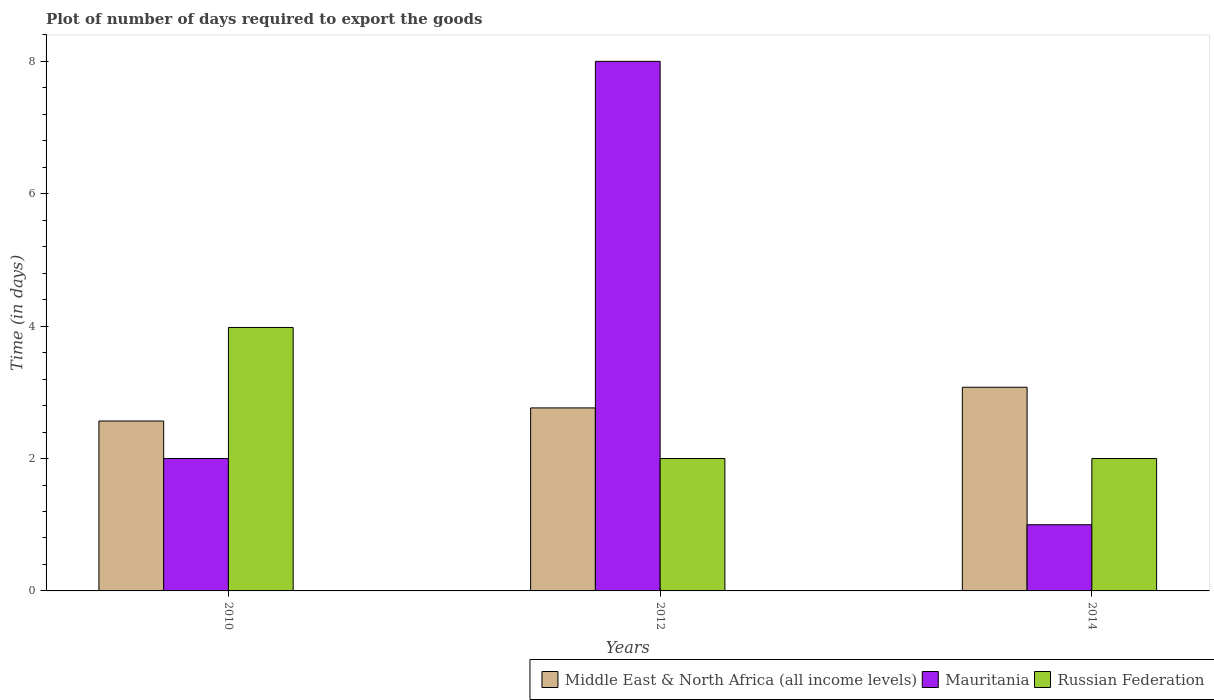How many bars are there on the 1st tick from the left?
Ensure brevity in your answer.  3. How many bars are there on the 2nd tick from the right?
Your response must be concise. 3. What is the label of the 3rd group of bars from the left?
Offer a very short reply. 2014. What is the time required to export goods in Mauritania in 2014?
Ensure brevity in your answer.  1. Across all years, what is the maximum time required to export goods in Russian Federation?
Provide a short and direct response. 3.98. Across all years, what is the minimum time required to export goods in Russian Federation?
Offer a very short reply. 2. In which year was the time required to export goods in Middle East & North Africa (all income levels) maximum?
Give a very brief answer. 2014. In which year was the time required to export goods in Russian Federation minimum?
Offer a very short reply. 2012. What is the difference between the time required to export goods in Mauritania in 2010 and that in 2012?
Offer a very short reply. -6. What is the difference between the time required to export goods in Russian Federation in 2010 and the time required to export goods in Mauritania in 2012?
Offer a terse response. -4.02. What is the average time required to export goods in Mauritania per year?
Your answer should be very brief. 3.67. In the year 2012, what is the difference between the time required to export goods in Russian Federation and time required to export goods in Middle East & North Africa (all income levels)?
Ensure brevity in your answer.  -0.76. What is the ratio of the time required to export goods in Middle East & North Africa (all income levels) in 2012 to that in 2014?
Your answer should be compact. 0.9. Is the time required to export goods in Mauritania in 2012 less than that in 2014?
Offer a terse response. No. What is the difference between the highest and the second highest time required to export goods in Middle East & North Africa (all income levels)?
Your answer should be very brief. 0.31. What is the difference between the highest and the lowest time required to export goods in Mauritania?
Offer a terse response. 7. In how many years, is the time required to export goods in Russian Federation greater than the average time required to export goods in Russian Federation taken over all years?
Offer a very short reply. 1. What does the 1st bar from the left in 2014 represents?
Your answer should be very brief. Middle East & North Africa (all income levels). What does the 2nd bar from the right in 2012 represents?
Provide a short and direct response. Mauritania. Are all the bars in the graph horizontal?
Your response must be concise. No. What is the difference between two consecutive major ticks on the Y-axis?
Offer a very short reply. 2. Are the values on the major ticks of Y-axis written in scientific E-notation?
Offer a very short reply. No. Does the graph contain any zero values?
Your response must be concise. No. Does the graph contain grids?
Give a very brief answer. No. How are the legend labels stacked?
Give a very brief answer. Horizontal. What is the title of the graph?
Your answer should be compact. Plot of number of days required to export the goods. Does "Comoros" appear as one of the legend labels in the graph?
Make the answer very short. No. What is the label or title of the X-axis?
Make the answer very short. Years. What is the label or title of the Y-axis?
Make the answer very short. Time (in days). What is the Time (in days) in Middle East & North Africa (all income levels) in 2010?
Offer a very short reply. 2.57. What is the Time (in days) of Mauritania in 2010?
Ensure brevity in your answer.  2. What is the Time (in days) in Russian Federation in 2010?
Ensure brevity in your answer.  3.98. What is the Time (in days) of Middle East & North Africa (all income levels) in 2012?
Offer a very short reply. 2.76. What is the Time (in days) of Mauritania in 2012?
Provide a succinct answer. 8. What is the Time (in days) of Russian Federation in 2012?
Your response must be concise. 2. What is the Time (in days) of Middle East & North Africa (all income levels) in 2014?
Your answer should be very brief. 3.08. What is the Time (in days) in Mauritania in 2014?
Give a very brief answer. 1. Across all years, what is the maximum Time (in days) in Middle East & North Africa (all income levels)?
Provide a succinct answer. 3.08. Across all years, what is the maximum Time (in days) in Russian Federation?
Your response must be concise. 3.98. Across all years, what is the minimum Time (in days) of Middle East & North Africa (all income levels)?
Provide a succinct answer. 2.57. Across all years, what is the minimum Time (in days) of Mauritania?
Your answer should be very brief. 1. Across all years, what is the minimum Time (in days) in Russian Federation?
Offer a terse response. 2. What is the total Time (in days) of Middle East & North Africa (all income levels) in the graph?
Offer a very short reply. 8.41. What is the total Time (in days) in Mauritania in the graph?
Ensure brevity in your answer.  11. What is the total Time (in days) in Russian Federation in the graph?
Your answer should be compact. 7.98. What is the difference between the Time (in days) of Middle East & North Africa (all income levels) in 2010 and that in 2012?
Your answer should be compact. -0.2. What is the difference between the Time (in days) in Russian Federation in 2010 and that in 2012?
Your answer should be compact. 1.98. What is the difference between the Time (in days) in Middle East & North Africa (all income levels) in 2010 and that in 2014?
Offer a very short reply. -0.51. What is the difference between the Time (in days) of Russian Federation in 2010 and that in 2014?
Provide a short and direct response. 1.98. What is the difference between the Time (in days) in Middle East & North Africa (all income levels) in 2012 and that in 2014?
Ensure brevity in your answer.  -0.31. What is the difference between the Time (in days) of Mauritania in 2012 and that in 2014?
Your response must be concise. 7. What is the difference between the Time (in days) of Russian Federation in 2012 and that in 2014?
Your answer should be very brief. 0. What is the difference between the Time (in days) of Middle East & North Africa (all income levels) in 2010 and the Time (in days) of Mauritania in 2012?
Offer a terse response. -5.43. What is the difference between the Time (in days) of Middle East & North Africa (all income levels) in 2010 and the Time (in days) of Russian Federation in 2012?
Ensure brevity in your answer.  0.57. What is the difference between the Time (in days) of Mauritania in 2010 and the Time (in days) of Russian Federation in 2012?
Provide a succinct answer. 0. What is the difference between the Time (in days) of Middle East & North Africa (all income levels) in 2010 and the Time (in days) of Mauritania in 2014?
Make the answer very short. 1.57. What is the difference between the Time (in days) in Middle East & North Africa (all income levels) in 2010 and the Time (in days) in Russian Federation in 2014?
Keep it short and to the point. 0.57. What is the difference between the Time (in days) of Mauritania in 2010 and the Time (in days) of Russian Federation in 2014?
Your response must be concise. 0. What is the difference between the Time (in days) of Middle East & North Africa (all income levels) in 2012 and the Time (in days) of Mauritania in 2014?
Provide a short and direct response. 1.76. What is the difference between the Time (in days) in Middle East & North Africa (all income levels) in 2012 and the Time (in days) in Russian Federation in 2014?
Provide a succinct answer. 0.76. What is the difference between the Time (in days) in Mauritania in 2012 and the Time (in days) in Russian Federation in 2014?
Ensure brevity in your answer.  6. What is the average Time (in days) of Middle East & North Africa (all income levels) per year?
Provide a succinct answer. 2.8. What is the average Time (in days) in Mauritania per year?
Give a very brief answer. 3.67. What is the average Time (in days) of Russian Federation per year?
Your response must be concise. 2.66. In the year 2010, what is the difference between the Time (in days) of Middle East & North Africa (all income levels) and Time (in days) of Mauritania?
Provide a succinct answer. 0.57. In the year 2010, what is the difference between the Time (in days) in Middle East & North Africa (all income levels) and Time (in days) in Russian Federation?
Offer a terse response. -1.41. In the year 2010, what is the difference between the Time (in days) of Mauritania and Time (in days) of Russian Federation?
Give a very brief answer. -1.98. In the year 2012, what is the difference between the Time (in days) in Middle East & North Africa (all income levels) and Time (in days) in Mauritania?
Make the answer very short. -5.24. In the year 2012, what is the difference between the Time (in days) in Middle East & North Africa (all income levels) and Time (in days) in Russian Federation?
Make the answer very short. 0.76. In the year 2012, what is the difference between the Time (in days) of Mauritania and Time (in days) of Russian Federation?
Provide a short and direct response. 6. In the year 2014, what is the difference between the Time (in days) in Middle East & North Africa (all income levels) and Time (in days) in Mauritania?
Provide a short and direct response. 2.08. In the year 2014, what is the difference between the Time (in days) of Middle East & North Africa (all income levels) and Time (in days) of Russian Federation?
Offer a terse response. 1.08. What is the ratio of the Time (in days) in Middle East & North Africa (all income levels) in 2010 to that in 2012?
Offer a very short reply. 0.93. What is the ratio of the Time (in days) in Russian Federation in 2010 to that in 2012?
Make the answer very short. 1.99. What is the ratio of the Time (in days) in Middle East & North Africa (all income levels) in 2010 to that in 2014?
Offer a terse response. 0.83. What is the ratio of the Time (in days) of Mauritania in 2010 to that in 2014?
Make the answer very short. 2. What is the ratio of the Time (in days) of Russian Federation in 2010 to that in 2014?
Offer a very short reply. 1.99. What is the ratio of the Time (in days) of Middle East & North Africa (all income levels) in 2012 to that in 2014?
Give a very brief answer. 0.9. What is the ratio of the Time (in days) of Mauritania in 2012 to that in 2014?
Provide a short and direct response. 8. What is the difference between the highest and the second highest Time (in days) of Middle East & North Africa (all income levels)?
Offer a terse response. 0.31. What is the difference between the highest and the second highest Time (in days) in Mauritania?
Your answer should be very brief. 6. What is the difference between the highest and the second highest Time (in days) of Russian Federation?
Keep it short and to the point. 1.98. What is the difference between the highest and the lowest Time (in days) of Middle East & North Africa (all income levels)?
Your answer should be very brief. 0.51. What is the difference between the highest and the lowest Time (in days) of Mauritania?
Your answer should be very brief. 7. What is the difference between the highest and the lowest Time (in days) in Russian Federation?
Make the answer very short. 1.98. 